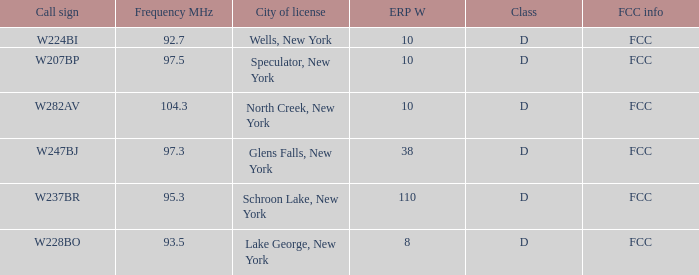Name the average ERP W and call sign of w237br 110.0. 